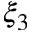<formula> <loc_0><loc_0><loc_500><loc_500>\xi _ { 3 }</formula> 